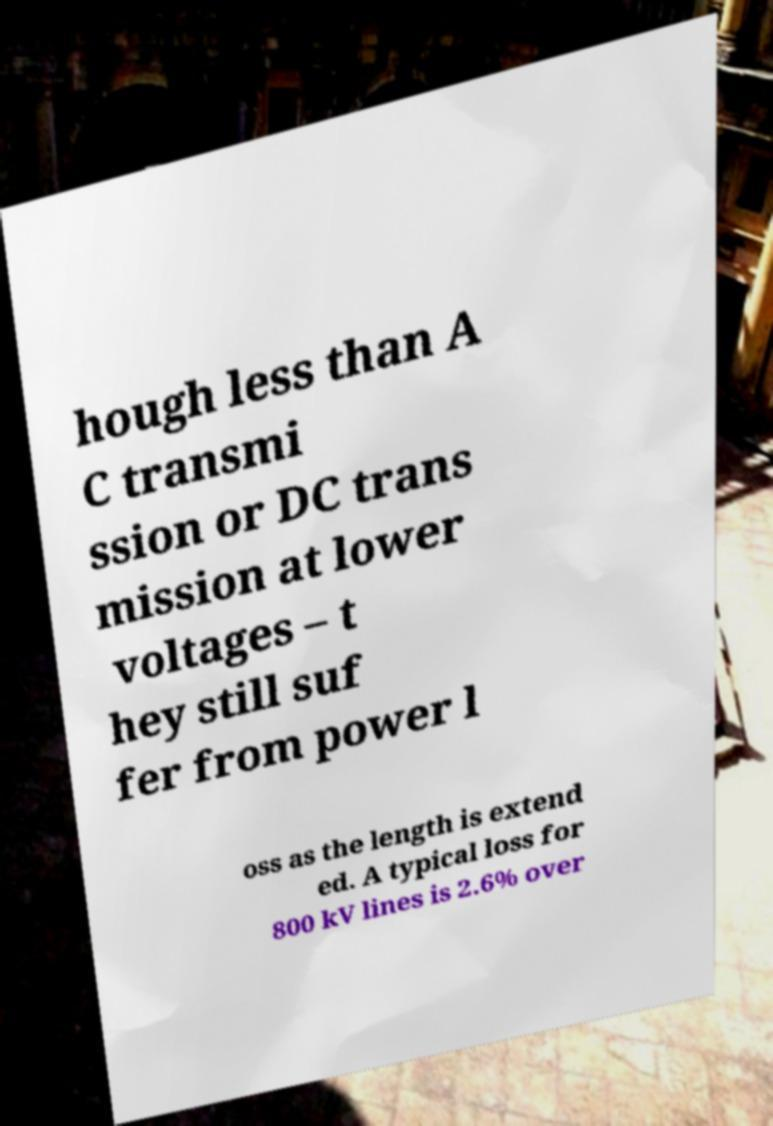Please read and relay the text visible in this image. What does it say? hough less than A C transmi ssion or DC trans mission at lower voltages – t hey still suf fer from power l oss as the length is extend ed. A typical loss for 800 kV lines is 2.6% over 